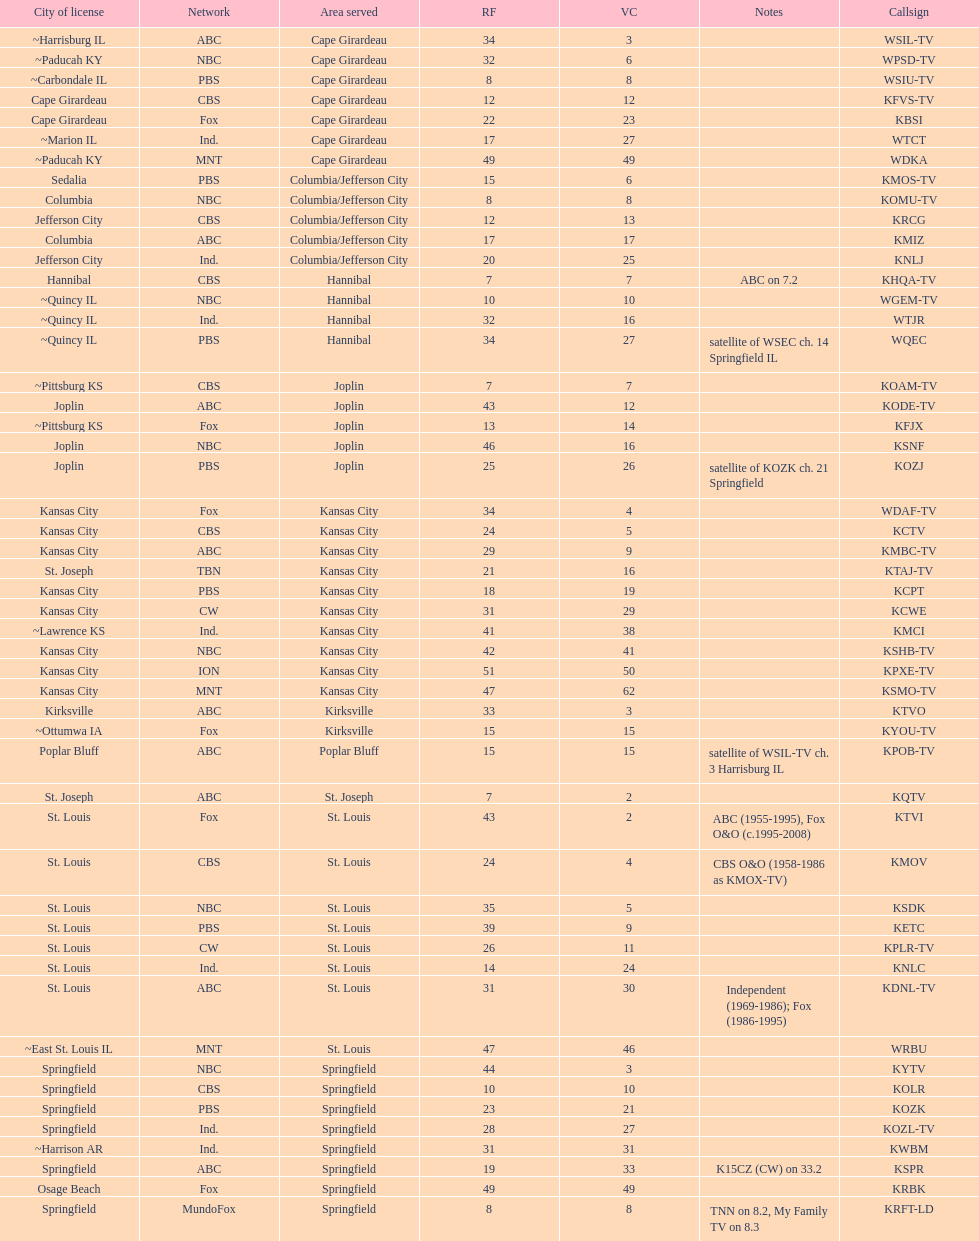What is the total number of cbs stations? 7. 